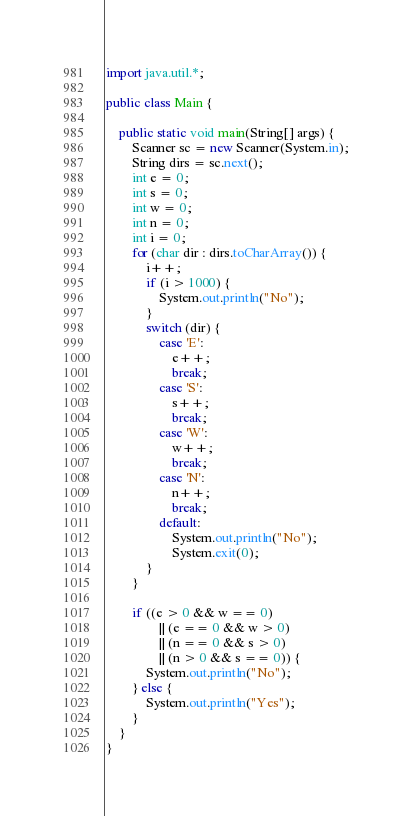<code> <loc_0><loc_0><loc_500><loc_500><_Java_>
import java.util.*;

public class Main {

    public static void main(String[] args) {
        Scanner sc = new Scanner(System.in);
        String dirs = sc.next();
        int e = 0;
        int s = 0;
        int w = 0;
        int n = 0;
        int i = 0;
        for (char dir : dirs.toCharArray()) {
            i++;
            if (i > 1000) {
                System.out.println("No");
            }
            switch (dir) {
                case 'E':
                    e++;
                    break;
                case 'S':
                    s++;
                    break;
                case 'W':
                    w++;
                    break;
                case 'N':
                    n++;
                    break;
                default:
                    System.out.println("No");
                    System.exit(0);
            }
        }

        if ((e > 0 && w == 0)
                || (e == 0 && w > 0)
                || (n == 0 && s > 0)
                || (n > 0 && s == 0)) {
            System.out.println("No");
        } else {
            System.out.println("Yes");
        }
    }
}
</code> 